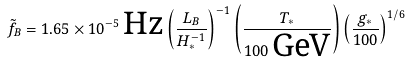Convert formula to latex. <formula><loc_0><loc_0><loc_500><loc_500>\tilde { f } _ { B } = 1 . 6 5 \times 1 0 ^ { - 5 } \, \text {Hz} \left ( \frac { L _ { B } } { H ^ { - 1 } _ { * } } \right ) ^ { - 1 } \left ( \frac { T _ { * } } { 1 0 0 \, \text {GeV} } \right ) \left ( \frac { g _ { * } } { 1 0 0 } \right ) ^ { 1 / 6 }</formula> 